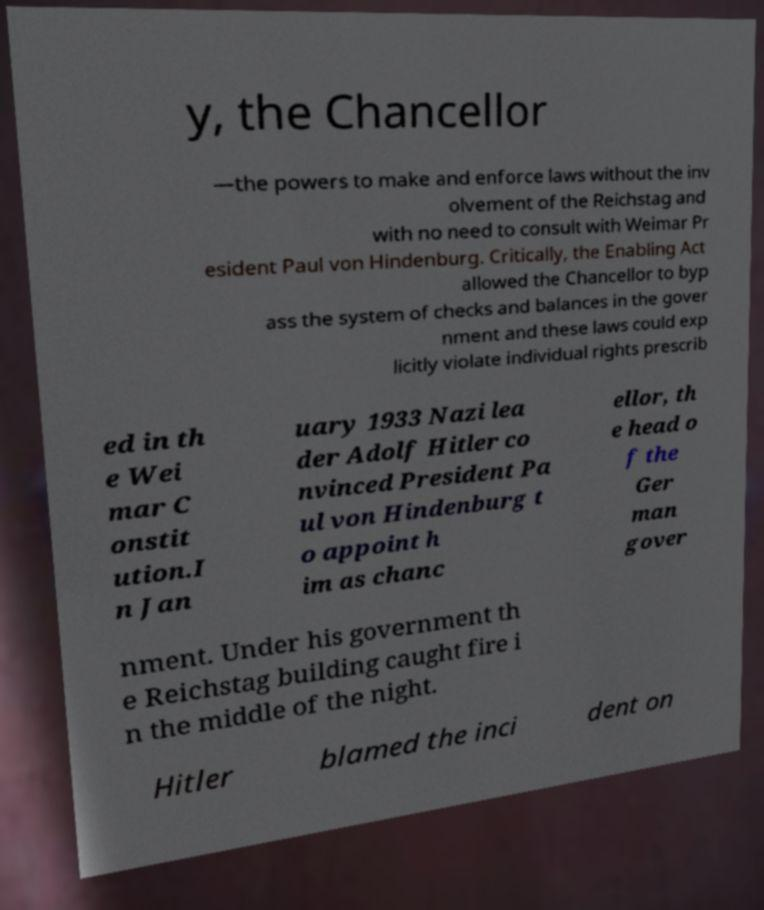Could you extract and type out the text from this image? y, the Chancellor —the powers to make and enforce laws without the inv olvement of the Reichstag and with no need to consult with Weimar Pr esident Paul von Hindenburg. Critically, the Enabling Act allowed the Chancellor to byp ass the system of checks and balances in the gover nment and these laws could exp licitly violate individual rights prescrib ed in th e Wei mar C onstit ution.I n Jan uary 1933 Nazi lea der Adolf Hitler co nvinced President Pa ul von Hindenburg t o appoint h im as chanc ellor, th e head o f the Ger man gover nment. Under his government th e Reichstag building caught fire i n the middle of the night. Hitler blamed the inci dent on 